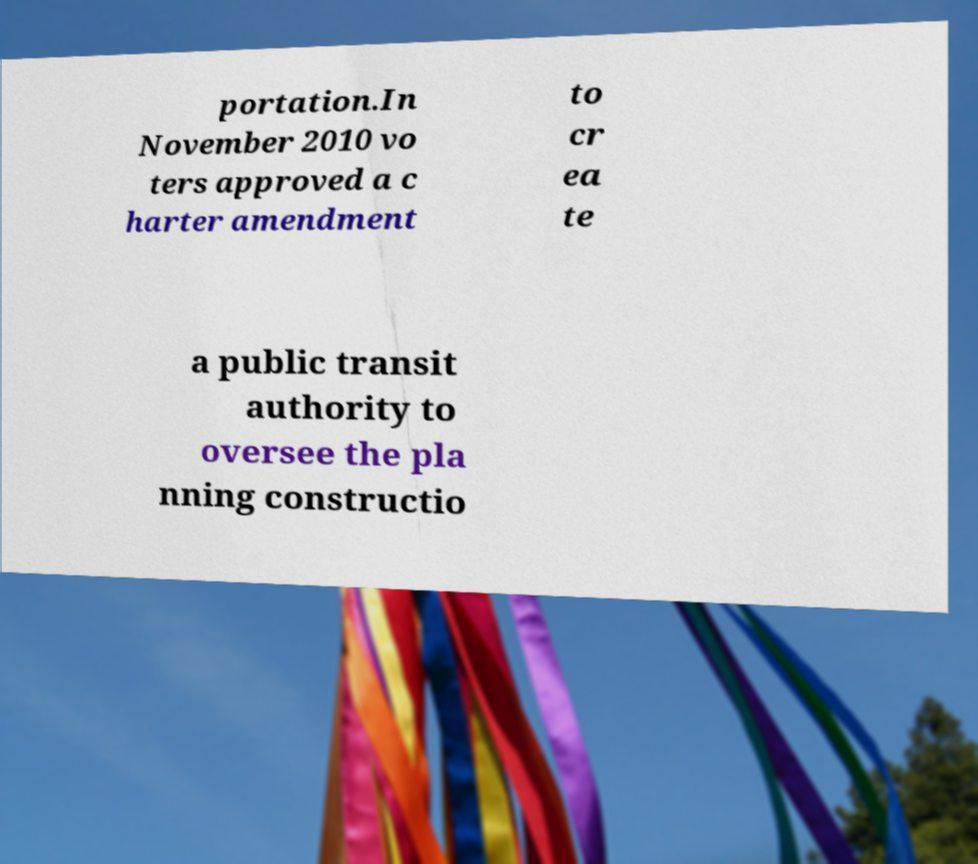What messages or text are displayed in this image? I need them in a readable, typed format. portation.In November 2010 vo ters approved a c harter amendment to cr ea te a public transit authority to oversee the pla nning constructio 